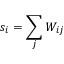Convert formula to latex. <formula><loc_0><loc_0><loc_500><loc_500>s _ { i } = \sum _ { j } W _ { i j }</formula> 